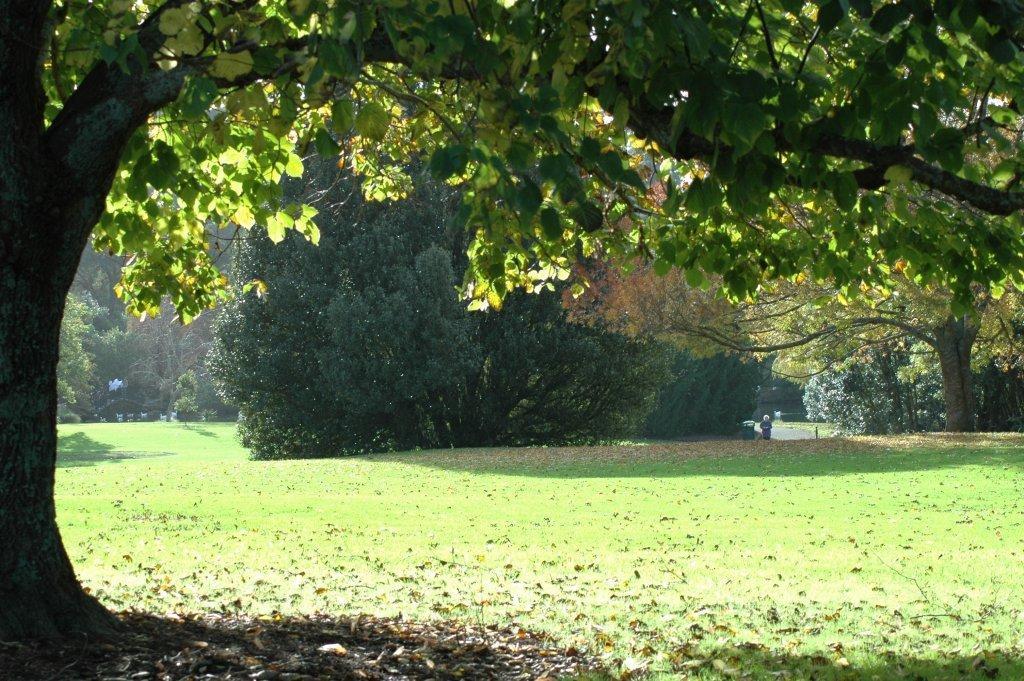Could you give a brief overview of what you see in this image? In this image we can see grass, dried leaves, and trees. 